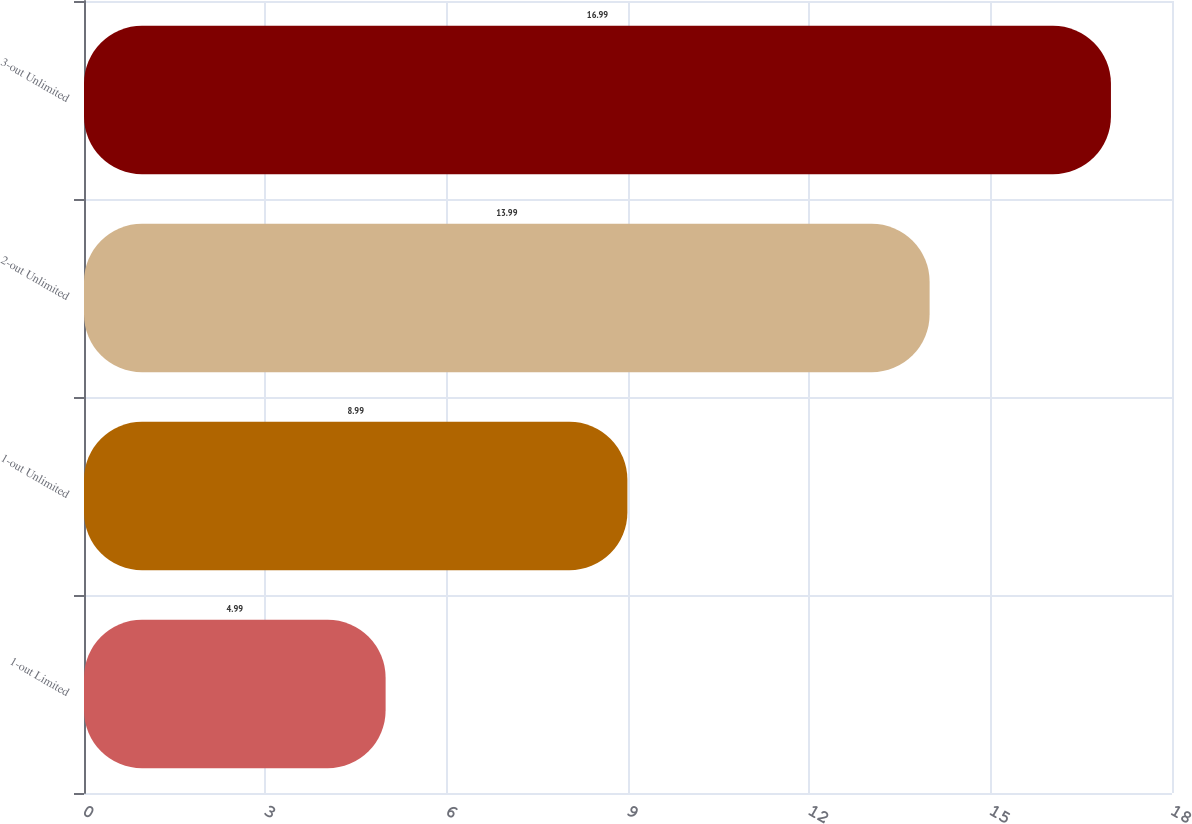<chart> <loc_0><loc_0><loc_500><loc_500><bar_chart><fcel>1-out Limited<fcel>1-out Unlimited<fcel>2-out Unlimited<fcel>3-out Unlimited<nl><fcel>4.99<fcel>8.99<fcel>13.99<fcel>16.99<nl></chart> 